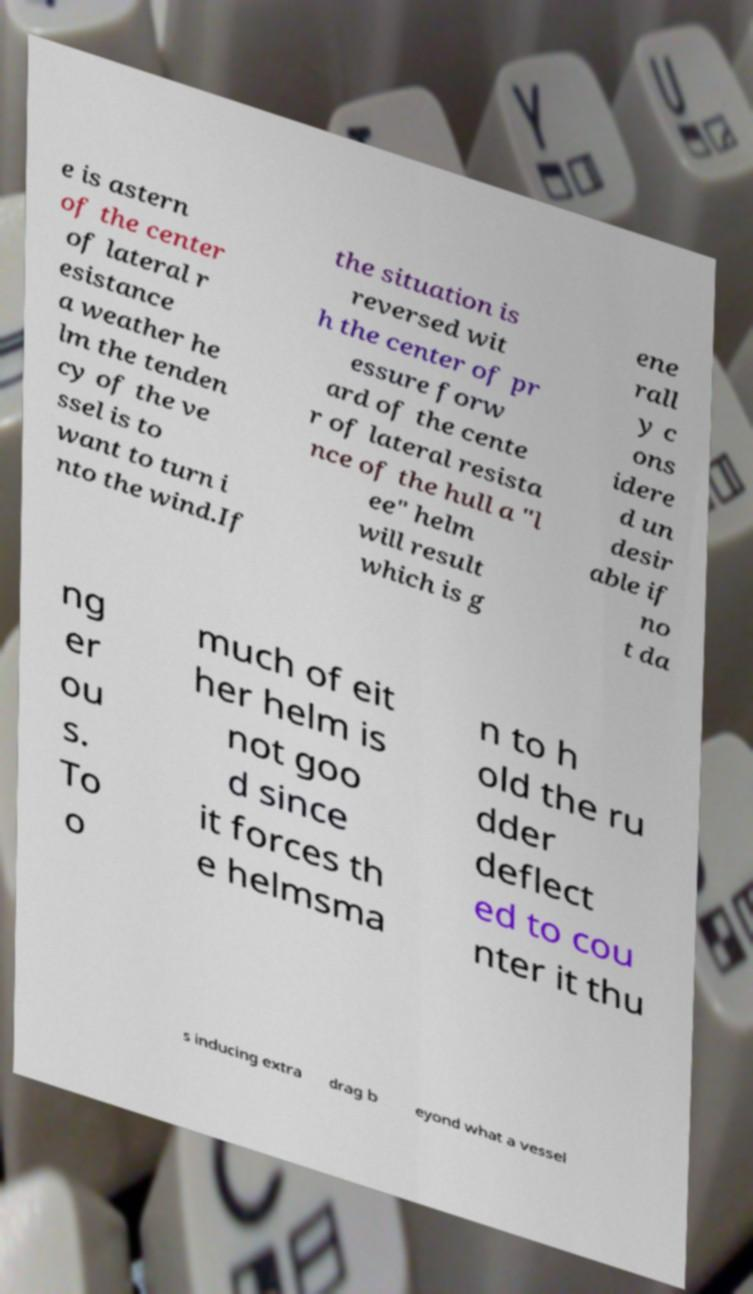What messages or text are displayed in this image? I need them in a readable, typed format. e is astern of the center of lateral r esistance a weather he lm the tenden cy of the ve ssel is to want to turn i nto the wind.If the situation is reversed wit h the center of pr essure forw ard of the cente r of lateral resista nce of the hull a "l ee" helm will result which is g ene rall y c ons idere d un desir able if no t da ng er ou s. To o much of eit her helm is not goo d since it forces th e helmsma n to h old the ru dder deflect ed to cou nter it thu s inducing extra drag b eyond what a vessel 